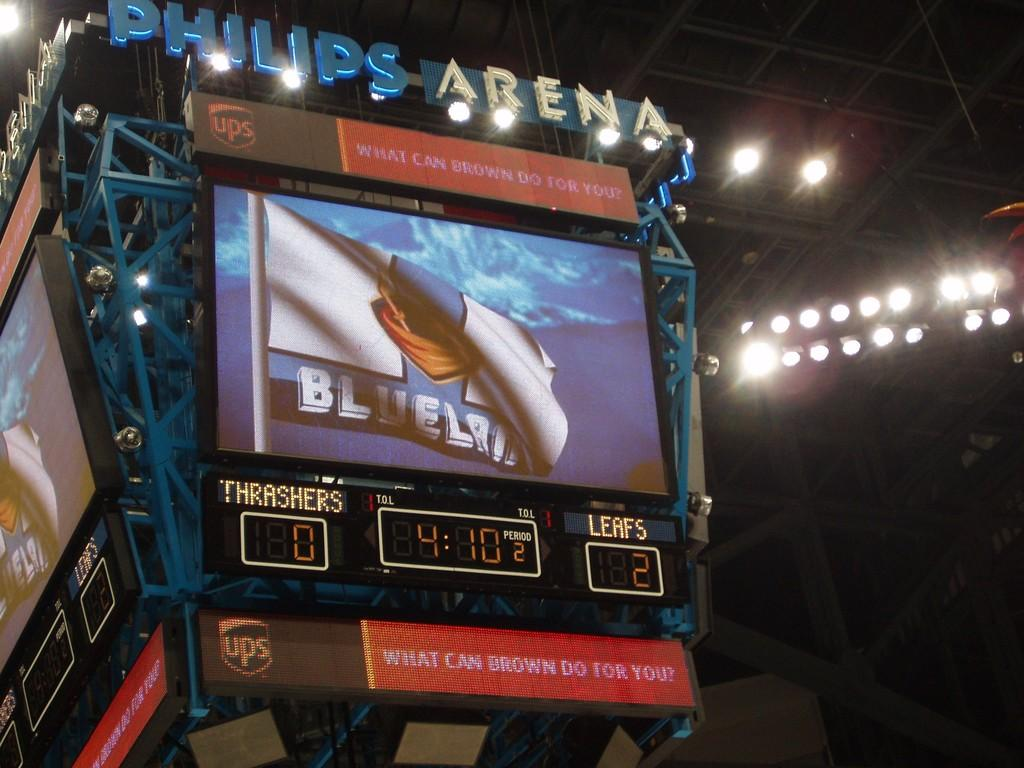<image>
Describe the image concisely. A advertisement for UPS asks what brown can do for you. 